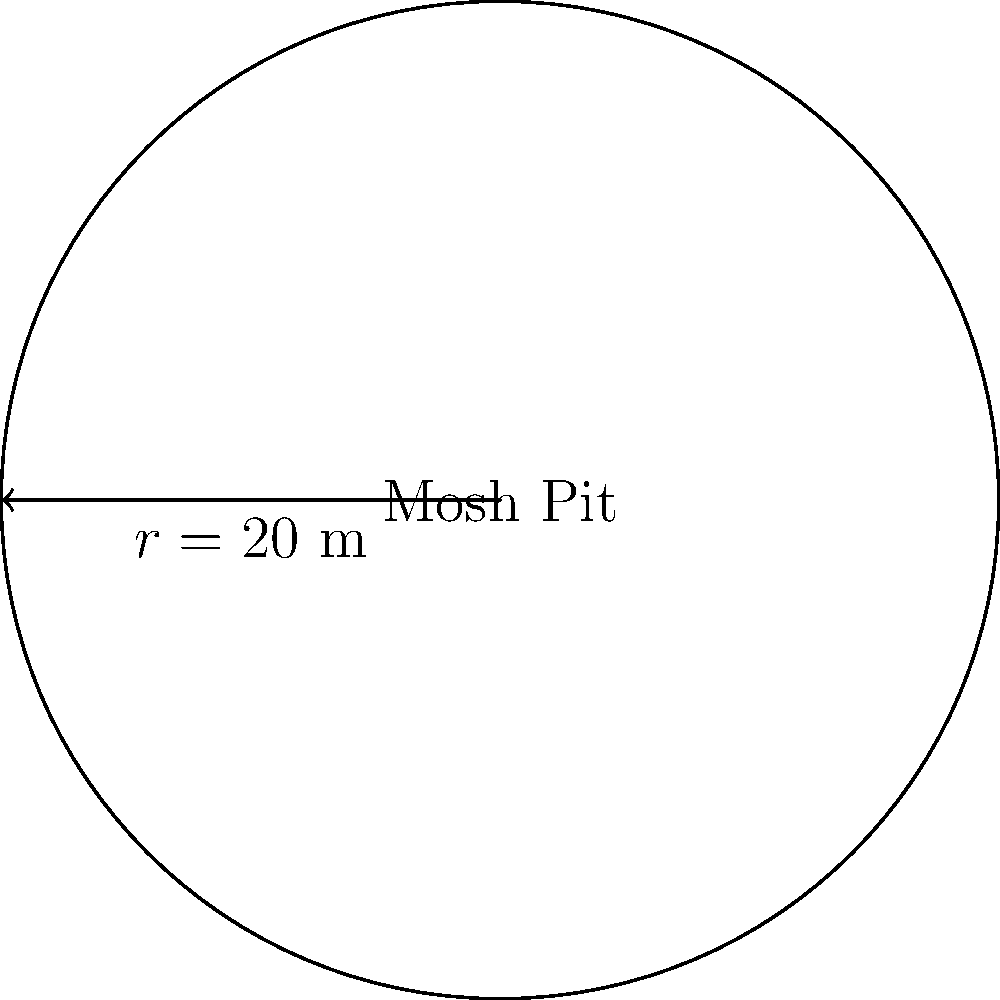At The Veldt's upcoming music festival, organizers are planning a circular mosh pit. If the radius of the mosh pit is 20 meters, what is the perimeter of the area where fans will be dancing? To find the perimeter of the circular mosh pit, we need to use the formula for the circumference of a circle:

$$C = 2\pi r$$

Where:
$C$ = circumference (perimeter)
$\pi$ = pi (approximately 3.14159)
$r$ = radius

Given:
$r = 20$ meters

Let's substitute the values into the formula:

$$C = 2\pi(20)$$
$$C = 40\pi$$

Now, let's calculate the final value:

$$C \approx 40 * 3.14159 \approx 125.66 \text{ meters}$$

Therefore, the perimeter of the circular mosh pit is approximately 125.66 meters.
Answer: $125.66$ meters 